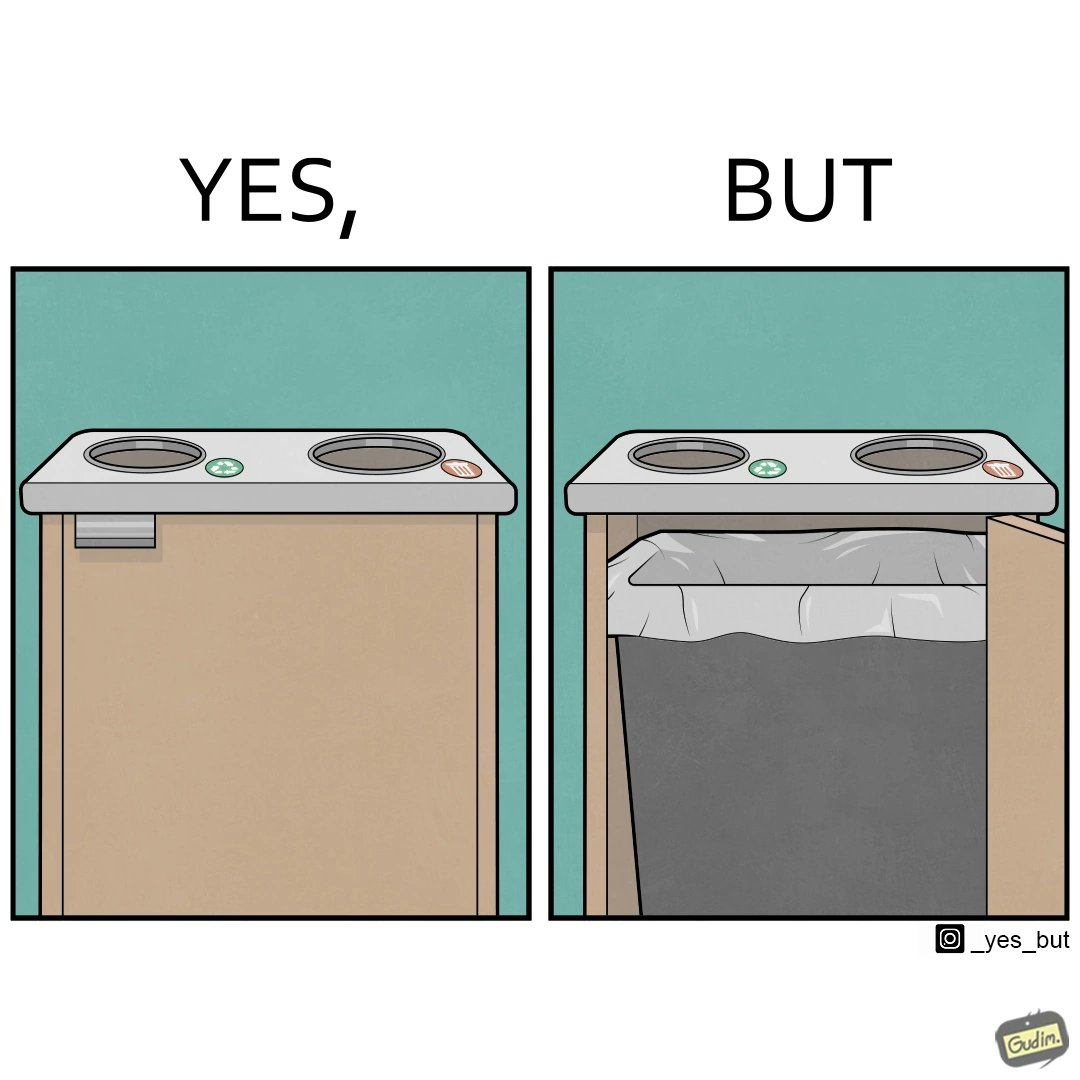What is shown in this image? The image is funny because while there are different holes provided to dump different kinds of waste, the separation is meaningless because the underlying bin which is the same. So all kinds of trash is collected together and can not be used for recycling. 